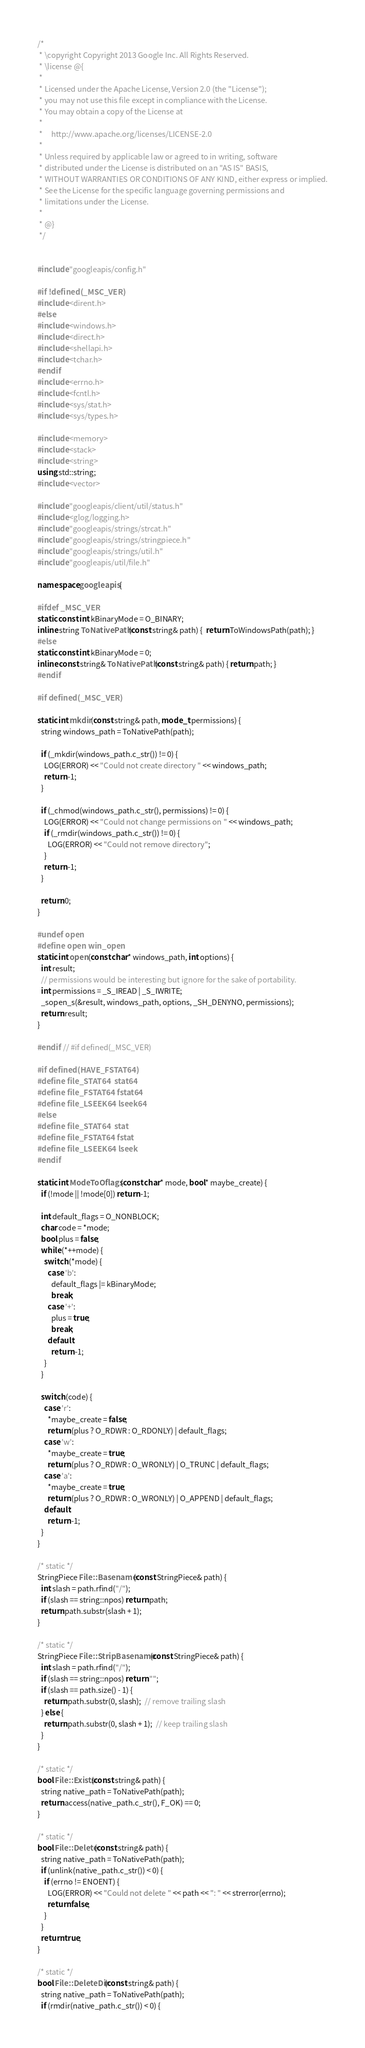<code> <loc_0><loc_0><loc_500><loc_500><_C++_>/*
 * \copyright Copyright 2013 Google Inc. All Rights Reserved.
 * \license @{
 *
 * Licensed under the Apache License, Version 2.0 (the "License");
 * you may not use this file except in compliance with the License.
 * You may obtain a copy of the License at
 *
 *     http://www.apache.org/licenses/LICENSE-2.0
 *
 * Unless required by applicable law or agreed to in writing, software
 * distributed under the License is distributed on an "AS IS" BASIS,
 * WITHOUT WARRANTIES OR CONDITIONS OF ANY KIND, either express or implied.
 * See the License for the specific language governing permissions and
 * limitations under the License.
 *
 * @}
 */


#include "googleapis/config.h"

#if !defined(_MSC_VER)
#include <dirent.h>
#else
#include <windows.h>
#include <direct.h>
#include <shellapi.h>
#include <tchar.h>
#endif
#include <errno.h>
#include <fcntl.h>
#include <sys/stat.h>
#include <sys/types.h>

#include <memory>
#include <stack>
#include <string>
using std::string;
#include <vector>

#include "googleapis/client/util/status.h"
#include <glog/logging.h>
#include "googleapis/strings/strcat.h"
#include "googleapis/strings/stringpiece.h"
#include "googleapis/strings/util.h"
#include "googleapis/util/file.h"

namespace googleapis {

#ifdef _MSC_VER
static const int kBinaryMode = O_BINARY;
inline string ToNativePath(const string& path) {  return ToWindowsPath(path); }
#else
static const int kBinaryMode = 0;
inline const string& ToNativePath(const string& path) { return path; }
#endif

#if defined(_MSC_VER)

static int mkdir(const string& path, mode_t permissions) {
  string windows_path = ToNativePath(path);

  if (_mkdir(windows_path.c_str()) != 0) {
    LOG(ERROR) << "Could not create directory " << windows_path;
    return -1;
  }

  if (_chmod(windows_path.c_str(), permissions) != 0) {
    LOG(ERROR) << "Could not change permissions on " << windows_path;
    if (_rmdir(windows_path.c_str()) != 0) {
      LOG(ERROR) << "Could not remove directory";
    }
    return -1;
  }

  return 0;
}

#undef open
#define open win_open
static int open(const char* windows_path, int options) {
  int result;
  // permissions would be interesting but ignore for the sake of portability.
  int permissions = _S_IREAD | _S_IWRITE;
  _sopen_s(&result, windows_path, options, _SH_DENYNO, permissions);
  return result;
}

#endif  // #if defined(_MSC_VER)

#if defined(HAVE_FSTAT64)
#define file_STAT64  stat64
#define file_FSTAT64 fstat64
#define file_LSEEK64 lseek64
#else
#define file_STAT64  stat
#define file_FSTAT64 fstat
#define file_LSEEK64 lseek
#endif

static int ModeToOflags(const char* mode, bool* maybe_create) {
  if (!mode || !mode[0]) return -1;

  int default_flags = O_NONBLOCK;
  char code = *mode;
  bool plus = false;
  while (*++mode) {
    switch (*mode) {
      case 'b':
        default_flags |= kBinaryMode;
        break;
      case '+':
        plus = true;
        break;
      default:
        return -1;
    }
  }

  switch (code) {
    case 'r':
      *maybe_create = false;
      return (plus ? O_RDWR : O_RDONLY) | default_flags;
    case 'w':
      *maybe_create = true;
      return (plus ? O_RDWR : O_WRONLY) | O_TRUNC | default_flags;
    case 'a':
      *maybe_create = true;
      return (plus ? O_RDWR : O_WRONLY) | O_APPEND | default_flags;
    default:
      return -1;
  }
}

/* static */
StringPiece File::Basename(const StringPiece& path) {
  int slash = path.rfind("/");
  if (slash == string::npos) return path;
  return path.substr(slash + 1);
}

/* static */
StringPiece File::StripBasename(const StringPiece& path) {
  int slash = path.rfind("/");
  if (slash == string::npos) return "";
  if (slash == path.size() - 1) {
    return path.substr(0, slash);  // remove trailing slash
  } else {
    return path.substr(0, slash + 1);  // keep trailing slash
  }
}

/* static */
bool File::Exists(const string& path) {
  string native_path = ToNativePath(path);
  return access(native_path.c_str(), F_OK) == 0;
}

/* static */
bool File::Delete(const string& path) {
  string native_path = ToNativePath(path);
  if (unlink(native_path.c_str()) < 0) {
    if (errno != ENOENT) {
      LOG(ERROR) << "Could not delete " << path << ": " << strerror(errno);
      return false;
    }
  }
  return true;
}

/* static */
bool File::DeleteDir(const string& path) {
  string native_path = ToNativePath(path);
  if (rmdir(native_path.c_str()) < 0) {</code> 